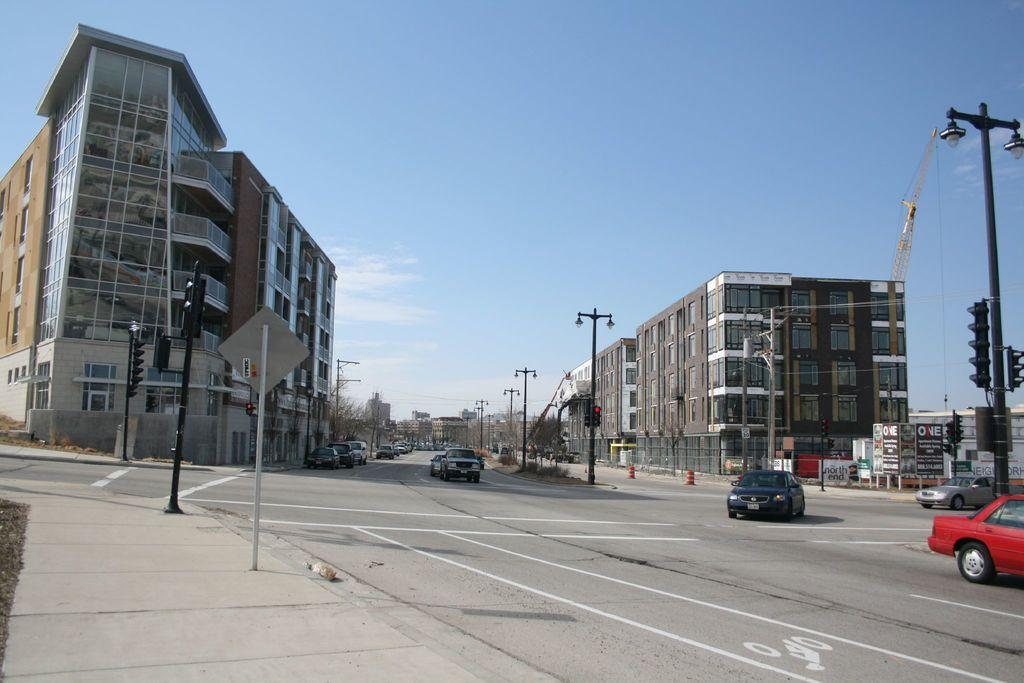What type of structures can be seen in the image? There are sign poles, street lamps, traffic signals, and buildings in the image. What type of vehicles are present in the image? There are cars in the image. What additional features can be seen in the image? There are banners in the image. What is visible in the background of the image? The sky is visible in the image. Can you tell me which actor is performing in the image? There is no actor present in the image; it features sign poles, street lamps, traffic signals, cars, buildings, banners, and the sky. What type of plantation can be seen in the image? There is no plantation present in the image; it features sign poles, street lamps, traffic signals, cars, buildings, banners, and the sky. 